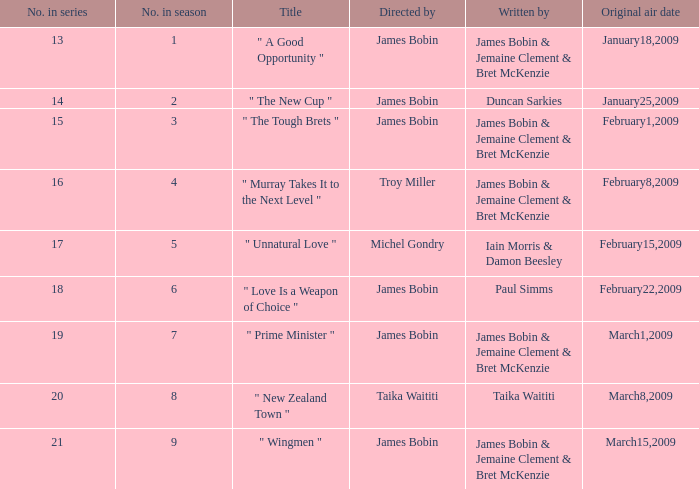 what's the original air date where written by is iain morris & damon beesley February15,2009. 